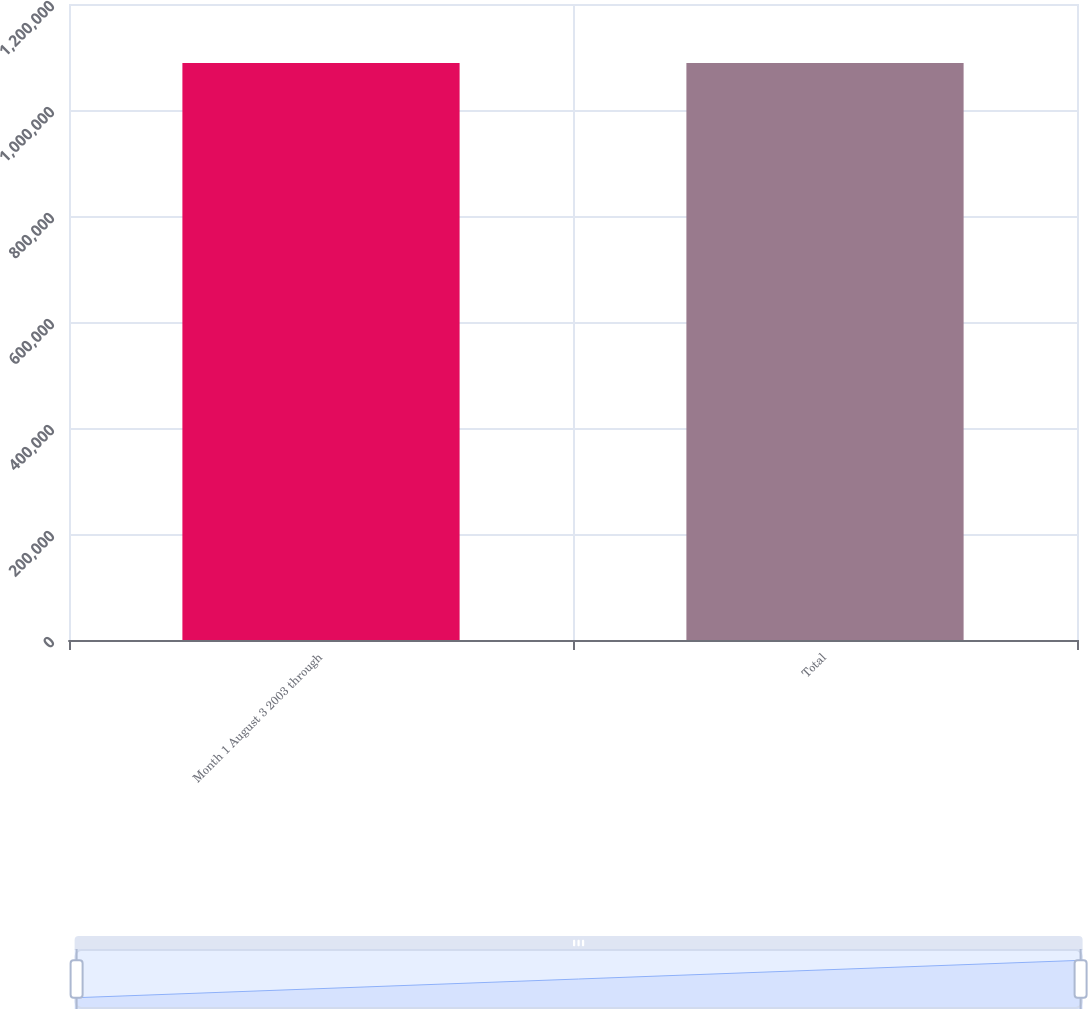<chart> <loc_0><loc_0><loc_500><loc_500><bar_chart><fcel>Month 1 August 3 2003 through<fcel>Total<nl><fcel>1.08861e+06<fcel>1.08861e+06<nl></chart> 